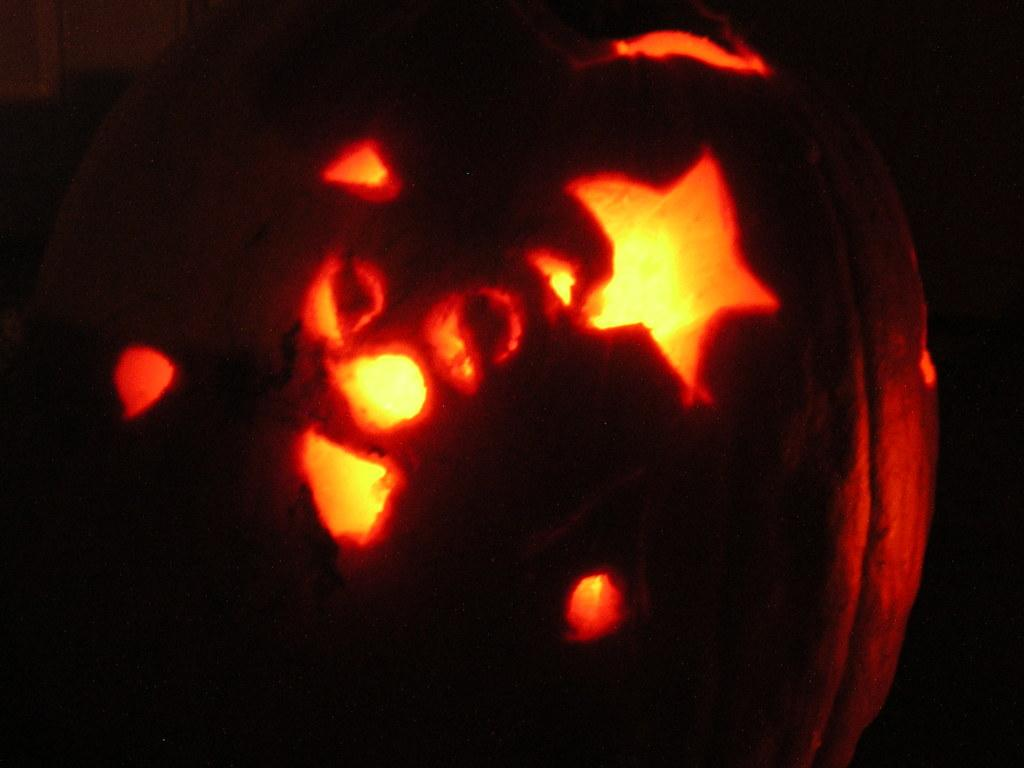What is the main subject of the Halloween-themed object in the image? The main subject of the Halloween-themed object in the image is not specified, but it is in the center of the image. What can be seen in addition to the Halloween-themed object? Lights are visible in the image. How would you describe the overall appearance of the image? The background of the image is dark. How many cards are being used in the image? There are no cards present in the image. 